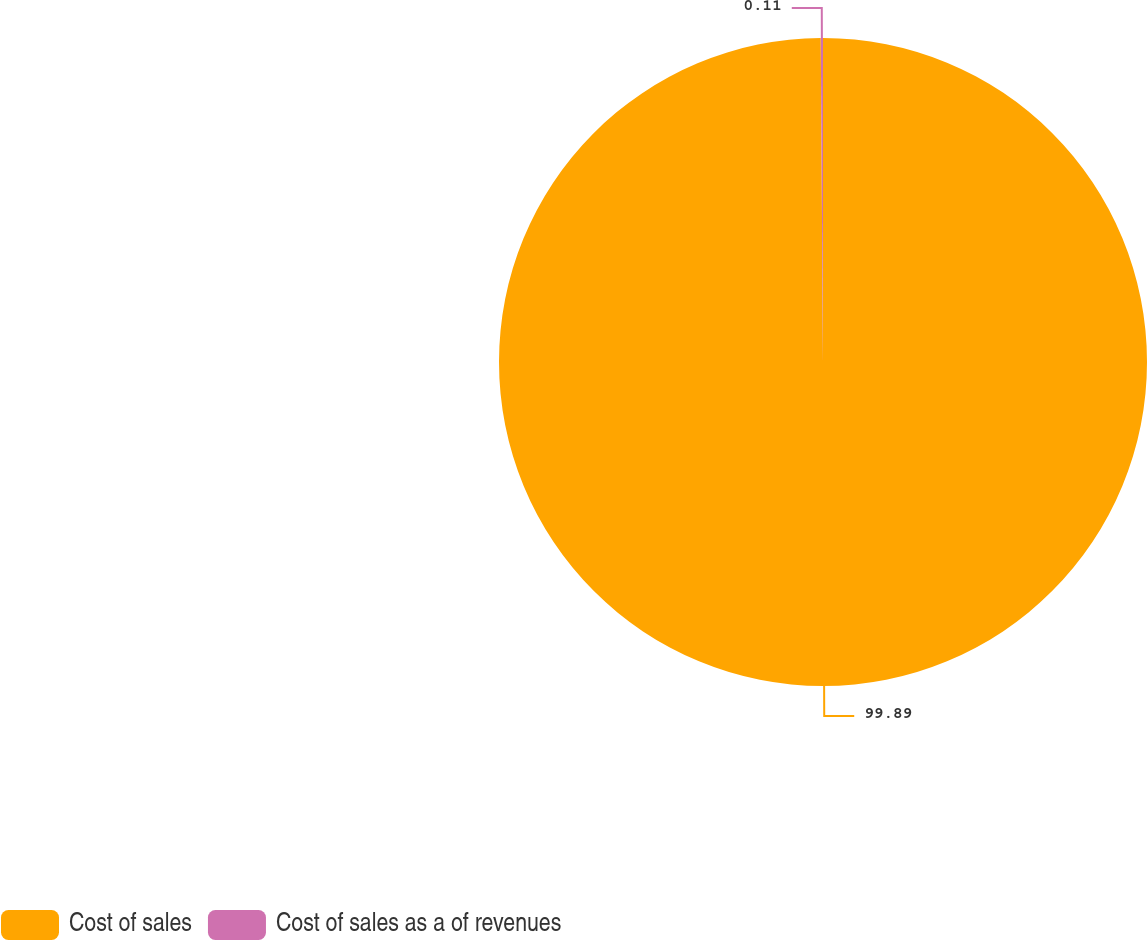<chart> <loc_0><loc_0><loc_500><loc_500><pie_chart><fcel>Cost of sales<fcel>Cost of sales as a of revenues<nl><fcel>99.89%<fcel>0.11%<nl></chart> 